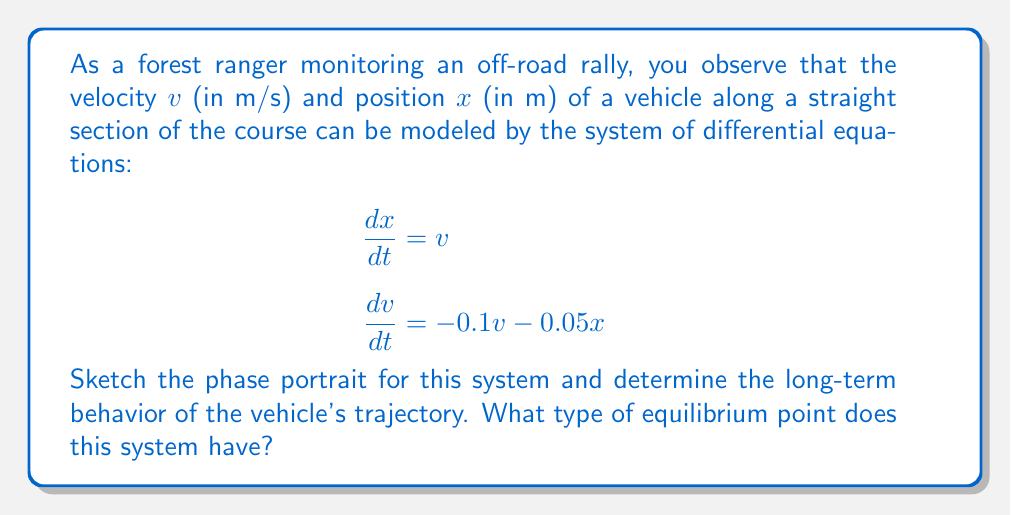Can you solve this math problem? Let's approach this step-by-step:

1) First, we need to identify the equilibrium point(s) of the system. This occurs when both $\frac{dx}{dt}$ and $\frac{dv}{dt}$ are zero:

   $\frac{dx}{dt} = v = 0$
   $\frac{dv}{dt} = -0.1v - 0.05x = 0$

   Solving this, we get $(x,v) = (0,0)$. So, $(0,0)$ is the only equilibrium point.

2) Next, we need to linearize the system around this equilibrium point. The Jacobian matrix at $(0,0)$ is:

   $$J = \begin{bmatrix}
   0 & 1 \\
   -0.05 & -0.1
   \end{bmatrix}$$

3) The eigenvalues of this matrix are given by the characteristic equation:

   $$\det(J - \lambda I) = \lambda^2 + 0.1\lambda + 0.05 = 0$$

   Solving this, we get $\lambda_1 \approx -0.0513$ and $\lambda_2 \approx -0.0487$

4) Since both eigenvalues are real and negative, this is a stable node.

5) The phase portrait will show trajectories converging to the origin from all directions. Here's a sketch:

[asy]
import graph;
size(200);
xaxis("x", Arrow);
yaxis("v", Arrow);

real f(real x, real y) { return y; }
real g(real x, real y) { return -0.1y - 0.05x; }

add(vectorfield(f, g, (-4,-4), (4,4), blue, 0.7));

for (real t = -3; t <= 3; t += 1) {
  draw((-4,t)--(4,t), gray+dashed);
  draw((t,-4)--(t,4), gray+dashed);
}

dot((0,0), red);
[/asy]

6) The long-term behavior of the vehicle's trajectory is to come to a stop at the origin. This makes sense physically: the negative terms in the equations represent friction and other resistive forces that eventually bring the vehicle to a halt.
Answer: Stable node at $(0,0)$ 